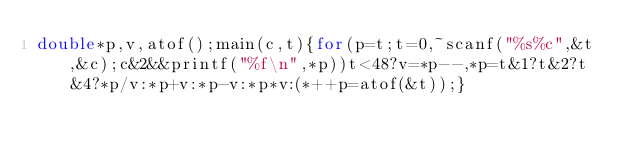<code> <loc_0><loc_0><loc_500><loc_500><_C_>double*p,v,atof();main(c,t){for(p=t;t=0,~scanf("%s%c",&t,&c);c&2&&printf("%f\n",*p))t<48?v=*p--,*p=t&1?t&2?t&4?*p/v:*p+v:*p-v:*p*v:(*++p=atof(&t));}</code> 